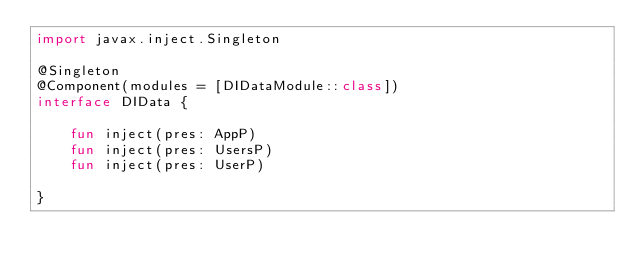<code> <loc_0><loc_0><loc_500><loc_500><_Kotlin_>import javax.inject.Singleton

@Singleton
@Component(modules = [DIDataModule::class])
interface DIData {

    fun inject(pres: AppP)
    fun inject(pres: UsersP)
    fun inject(pres: UserP)

}</code> 